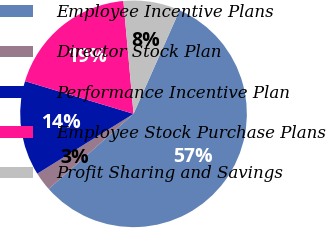Convert chart. <chart><loc_0><loc_0><loc_500><loc_500><pie_chart><fcel>Employee Incentive Plans<fcel>Director Stock Plan<fcel>Performance Incentive Plan<fcel>Employee Stock Purchase Plans<fcel>Profit Sharing and Savings<nl><fcel>56.8%<fcel>2.68%<fcel>13.51%<fcel>18.92%<fcel>8.09%<nl></chart> 